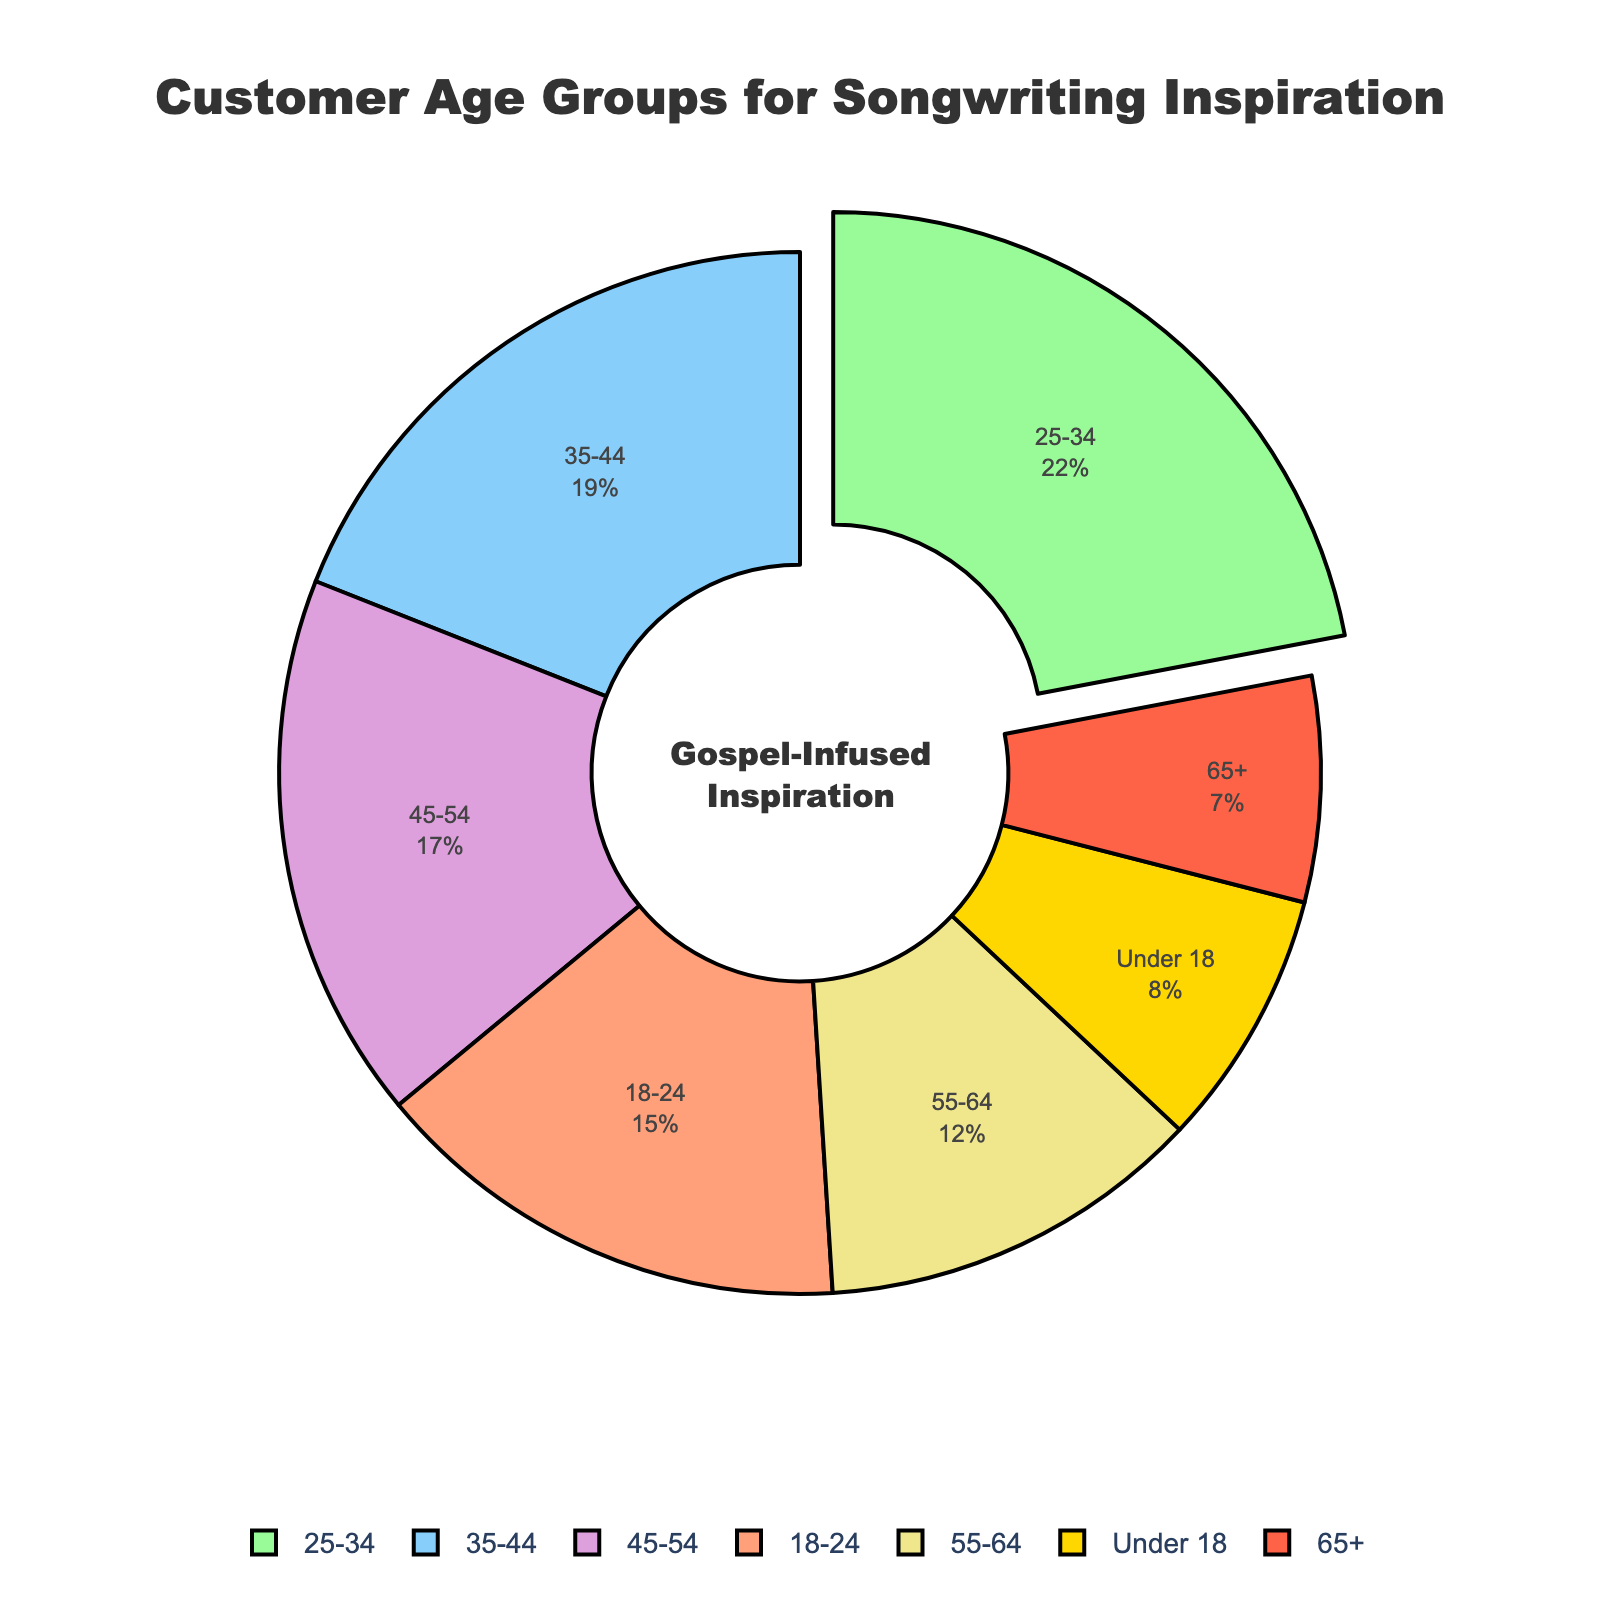What's the largest customer age group by percentage visiting the store for inspiration? The largest age group can be identified by looking for the section of the pie chart that is the biggest or is pulled out. The pulled-out section represents the age group with the highest percentage. This is the 25-34 age group at 22%.
Answer: 25-34 age group Which age group has the lowest percentage of visitors? The smallest section of the pie chart represents the age group with the lowest percentage. This is the 65+ age group at 7%.
Answer: 65+ age group How much more is the percentage of visitors aged 25-34 compared to those aged 18-24? Determine the percentages of both age groups and subtract the smaller percentage from the larger one. 25-34 is 22%, and 18-24 is 15%, so 22% - 15% = 7%.
Answer: 7% What is the combined percentage of visitors aged between 35-54? Add the percentage of the 35-44 group to the 45-54 group. 19% + 17% = 36%.
Answer: 36% How does the percentage of visitors aged 55-64 compare to those aged under 18? Compare the two percentages directly. The 55-64 age group has 12% and the under 18 age group has 8%. 12% is greater than 8%.
Answer: The percentage of visitors aged 55-64 is greater than those aged under 18 Which age groups have a percentage between 10% and 20%? Identify all segments of the pie chart that fall within these percentages. These include the 18-24 age group at 15%, 35-44 age group at 19%, 45-54 age group at 17%, and 55-64 age group at 12%.
Answer: 18-24, 35-44, 45-54, 55-64 What is the average percentage of visitors for the age groups 18-24, 25-34, and 35-44? Add the percentages of these groups and divide by the number of groups. (15% + 22% + 19%) / 3 = 56% / 3 ≈ 18.67%.
Answer: 18.67% How much is the difference between the percentage of visitors aged 45-54 and those aged 55-64? Subtract the smaller percentage from the larger one. 17% - 12% = 5%.
Answer: 5% What is the combined percentage of visitors aged under 18 and over 65? Add the percentages of both groups. 8% + 7% = 15%.
Answer: 15% What color represents the 35-44 age group in the chart? Identify the segment corresponding to the 35-44 age group and its color. The 35-44 age group is represented by a blue segment.
Answer: Blue 